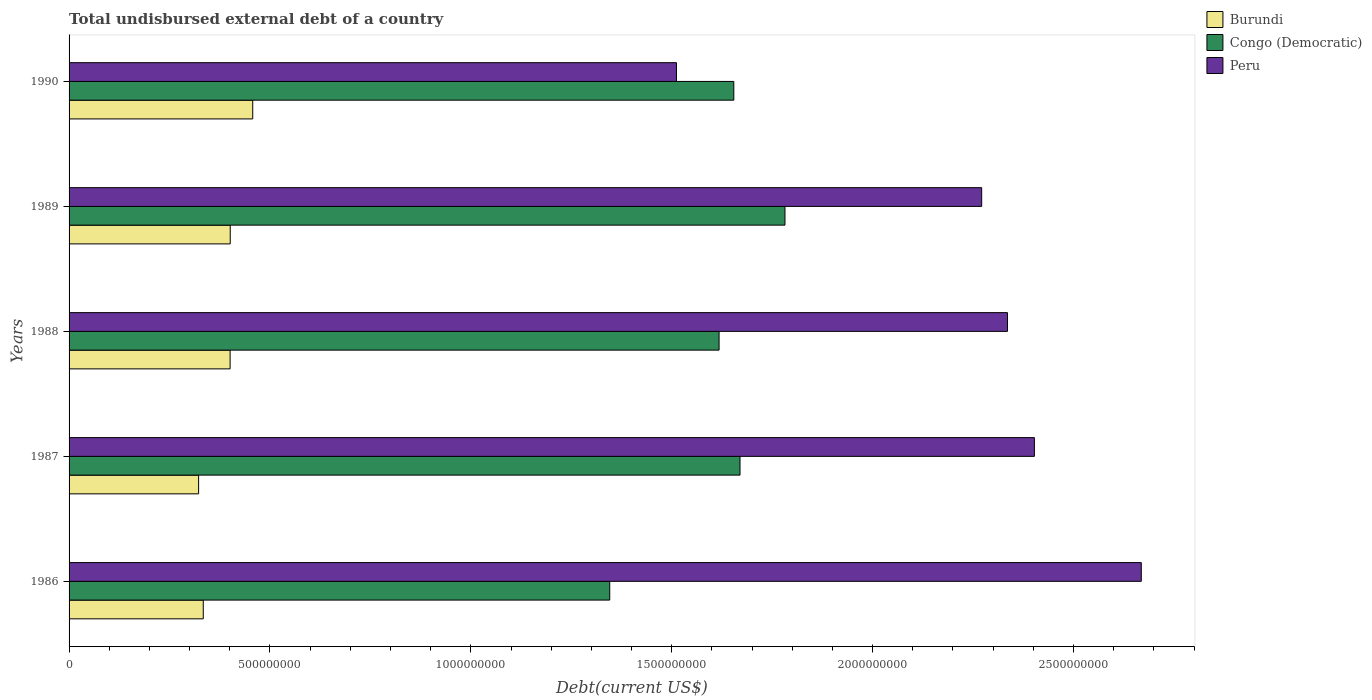What is the label of the 3rd group of bars from the top?
Give a very brief answer. 1988. In how many cases, is the number of bars for a given year not equal to the number of legend labels?
Your response must be concise. 0. What is the total undisbursed external debt in Congo (Democratic) in 1986?
Give a very brief answer. 1.35e+09. Across all years, what is the maximum total undisbursed external debt in Burundi?
Make the answer very short. 4.57e+08. Across all years, what is the minimum total undisbursed external debt in Burundi?
Offer a terse response. 3.22e+08. In which year was the total undisbursed external debt in Congo (Democratic) maximum?
Your answer should be very brief. 1989. What is the total total undisbursed external debt in Peru in the graph?
Give a very brief answer. 1.12e+1. What is the difference between the total undisbursed external debt in Congo (Democratic) in 1986 and that in 1989?
Your answer should be compact. -4.36e+08. What is the difference between the total undisbursed external debt in Congo (Democratic) in 1987 and the total undisbursed external debt in Peru in 1988?
Provide a short and direct response. -6.66e+08. What is the average total undisbursed external debt in Burundi per year?
Offer a very short reply. 3.83e+08. In the year 1987, what is the difference between the total undisbursed external debt in Peru and total undisbursed external debt in Burundi?
Your answer should be compact. 2.08e+09. In how many years, is the total undisbursed external debt in Burundi greater than 2500000000 US$?
Offer a very short reply. 0. What is the ratio of the total undisbursed external debt in Peru in 1988 to that in 1989?
Offer a very short reply. 1.03. Is the difference between the total undisbursed external debt in Peru in 1989 and 1990 greater than the difference between the total undisbursed external debt in Burundi in 1989 and 1990?
Give a very brief answer. Yes. What is the difference between the highest and the second highest total undisbursed external debt in Peru?
Offer a very short reply. 2.66e+08. What is the difference between the highest and the lowest total undisbursed external debt in Peru?
Your response must be concise. 1.16e+09. In how many years, is the total undisbursed external debt in Burundi greater than the average total undisbursed external debt in Burundi taken over all years?
Give a very brief answer. 3. Is the sum of the total undisbursed external debt in Burundi in 1986 and 1989 greater than the maximum total undisbursed external debt in Congo (Democratic) across all years?
Offer a terse response. No. What does the 2nd bar from the top in 1987 represents?
Your answer should be compact. Congo (Democratic). Is it the case that in every year, the sum of the total undisbursed external debt in Burundi and total undisbursed external debt in Congo (Democratic) is greater than the total undisbursed external debt in Peru?
Make the answer very short. No. How many years are there in the graph?
Give a very brief answer. 5. What is the difference between two consecutive major ticks on the X-axis?
Your answer should be very brief. 5.00e+08. Are the values on the major ticks of X-axis written in scientific E-notation?
Your answer should be compact. No. How are the legend labels stacked?
Make the answer very short. Vertical. What is the title of the graph?
Offer a very short reply. Total undisbursed external debt of a country. What is the label or title of the X-axis?
Your response must be concise. Debt(current US$). What is the label or title of the Y-axis?
Offer a very short reply. Years. What is the Debt(current US$) of Burundi in 1986?
Your answer should be compact. 3.34e+08. What is the Debt(current US$) of Congo (Democratic) in 1986?
Give a very brief answer. 1.35e+09. What is the Debt(current US$) in Peru in 1986?
Your answer should be very brief. 2.67e+09. What is the Debt(current US$) of Burundi in 1987?
Your response must be concise. 3.22e+08. What is the Debt(current US$) in Congo (Democratic) in 1987?
Give a very brief answer. 1.67e+09. What is the Debt(current US$) in Peru in 1987?
Your answer should be compact. 2.40e+09. What is the Debt(current US$) of Burundi in 1988?
Ensure brevity in your answer.  4.01e+08. What is the Debt(current US$) of Congo (Democratic) in 1988?
Your answer should be compact. 1.62e+09. What is the Debt(current US$) in Peru in 1988?
Your answer should be very brief. 2.34e+09. What is the Debt(current US$) in Burundi in 1989?
Provide a succinct answer. 4.01e+08. What is the Debt(current US$) of Congo (Democratic) in 1989?
Your response must be concise. 1.78e+09. What is the Debt(current US$) in Peru in 1989?
Make the answer very short. 2.27e+09. What is the Debt(current US$) in Burundi in 1990?
Provide a succinct answer. 4.57e+08. What is the Debt(current US$) of Congo (Democratic) in 1990?
Give a very brief answer. 1.65e+09. What is the Debt(current US$) of Peru in 1990?
Your answer should be compact. 1.51e+09. Across all years, what is the maximum Debt(current US$) in Burundi?
Your response must be concise. 4.57e+08. Across all years, what is the maximum Debt(current US$) of Congo (Democratic)?
Give a very brief answer. 1.78e+09. Across all years, what is the maximum Debt(current US$) of Peru?
Make the answer very short. 2.67e+09. Across all years, what is the minimum Debt(current US$) in Burundi?
Make the answer very short. 3.22e+08. Across all years, what is the minimum Debt(current US$) in Congo (Democratic)?
Your answer should be very brief. 1.35e+09. Across all years, what is the minimum Debt(current US$) in Peru?
Ensure brevity in your answer.  1.51e+09. What is the total Debt(current US$) of Burundi in the graph?
Make the answer very short. 1.92e+09. What is the total Debt(current US$) of Congo (Democratic) in the graph?
Offer a terse response. 8.07e+09. What is the total Debt(current US$) of Peru in the graph?
Offer a terse response. 1.12e+1. What is the difference between the Debt(current US$) in Burundi in 1986 and that in 1987?
Give a very brief answer. 1.16e+07. What is the difference between the Debt(current US$) of Congo (Democratic) in 1986 and that in 1987?
Provide a short and direct response. -3.24e+08. What is the difference between the Debt(current US$) of Peru in 1986 and that in 1987?
Offer a terse response. 2.66e+08. What is the difference between the Debt(current US$) in Burundi in 1986 and that in 1988?
Provide a succinct answer. -6.68e+07. What is the difference between the Debt(current US$) in Congo (Democratic) in 1986 and that in 1988?
Your response must be concise. -2.72e+08. What is the difference between the Debt(current US$) in Peru in 1986 and that in 1988?
Offer a terse response. 3.33e+08. What is the difference between the Debt(current US$) of Burundi in 1986 and that in 1989?
Offer a terse response. -6.71e+07. What is the difference between the Debt(current US$) in Congo (Democratic) in 1986 and that in 1989?
Your answer should be compact. -4.36e+08. What is the difference between the Debt(current US$) of Peru in 1986 and that in 1989?
Make the answer very short. 3.97e+08. What is the difference between the Debt(current US$) of Burundi in 1986 and that in 1990?
Provide a short and direct response. -1.23e+08. What is the difference between the Debt(current US$) in Congo (Democratic) in 1986 and that in 1990?
Your response must be concise. -3.09e+08. What is the difference between the Debt(current US$) of Peru in 1986 and that in 1990?
Your answer should be compact. 1.16e+09. What is the difference between the Debt(current US$) in Burundi in 1987 and that in 1988?
Make the answer very short. -7.84e+07. What is the difference between the Debt(current US$) of Congo (Democratic) in 1987 and that in 1988?
Your answer should be compact. 5.21e+07. What is the difference between the Debt(current US$) in Peru in 1987 and that in 1988?
Your answer should be very brief. 6.70e+07. What is the difference between the Debt(current US$) in Burundi in 1987 and that in 1989?
Your answer should be compact. -7.87e+07. What is the difference between the Debt(current US$) of Congo (Democratic) in 1987 and that in 1989?
Give a very brief answer. -1.12e+08. What is the difference between the Debt(current US$) in Peru in 1987 and that in 1989?
Make the answer very short. 1.31e+08. What is the difference between the Debt(current US$) of Burundi in 1987 and that in 1990?
Make the answer very short. -1.35e+08. What is the difference between the Debt(current US$) of Congo (Democratic) in 1987 and that in 1990?
Ensure brevity in your answer.  1.54e+07. What is the difference between the Debt(current US$) of Peru in 1987 and that in 1990?
Make the answer very short. 8.91e+08. What is the difference between the Debt(current US$) of Burundi in 1988 and that in 1989?
Your answer should be very brief. -3.04e+05. What is the difference between the Debt(current US$) of Congo (Democratic) in 1988 and that in 1989?
Make the answer very short. -1.64e+08. What is the difference between the Debt(current US$) of Peru in 1988 and that in 1989?
Offer a terse response. 6.43e+07. What is the difference between the Debt(current US$) of Burundi in 1988 and that in 1990?
Keep it short and to the point. -5.63e+07. What is the difference between the Debt(current US$) of Congo (Democratic) in 1988 and that in 1990?
Provide a short and direct response. -3.67e+07. What is the difference between the Debt(current US$) of Peru in 1988 and that in 1990?
Your answer should be compact. 8.24e+08. What is the difference between the Debt(current US$) of Burundi in 1989 and that in 1990?
Keep it short and to the point. -5.60e+07. What is the difference between the Debt(current US$) in Congo (Democratic) in 1989 and that in 1990?
Your answer should be very brief. 1.27e+08. What is the difference between the Debt(current US$) of Peru in 1989 and that in 1990?
Ensure brevity in your answer.  7.60e+08. What is the difference between the Debt(current US$) of Burundi in 1986 and the Debt(current US$) of Congo (Democratic) in 1987?
Offer a very short reply. -1.34e+09. What is the difference between the Debt(current US$) in Burundi in 1986 and the Debt(current US$) in Peru in 1987?
Offer a terse response. -2.07e+09. What is the difference between the Debt(current US$) of Congo (Democratic) in 1986 and the Debt(current US$) of Peru in 1987?
Provide a short and direct response. -1.06e+09. What is the difference between the Debt(current US$) of Burundi in 1986 and the Debt(current US$) of Congo (Democratic) in 1988?
Provide a succinct answer. -1.28e+09. What is the difference between the Debt(current US$) of Burundi in 1986 and the Debt(current US$) of Peru in 1988?
Ensure brevity in your answer.  -2.00e+09. What is the difference between the Debt(current US$) of Congo (Democratic) in 1986 and the Debt(current US$) of Peru in 1988?
Provide a short and direct response. -9.90e+08. What is the difference between the Debt(current US$) of Burundi in 1986 and the Debt(current US$) of Congo (Democratic) in 1989?
Keep it short and to the point. -1.45e+09. What is the difference between the Debt(current US$) of Burundi in 1986 and the Debt(current US$) of Peru in 1989?
Your answer should be compact. -1.94e+09. What is the difference between the Debt(current US$) of Congo (Democratic) in 1986 and the Debt(current US$) of Peru in 1989?
Keep it short and to the point. -9.26e+08. What is the difference between the Debt(current US$) of Burundi in 1986 and the Debt(current US$) of Congo (Democratic) in 1990?
Offer a terse response. -1.32e+09. What is the difference between the Debt(current US$) of Burundi in 1986 and the Debt(current US$) of Peru in 1990?
Offer a very short reply. -1.18e+09. What is the difference between the Debt(current US$) in Congo (Democratic) in 1986 and the Debt(current US$) in Peru in 1990?
Offer a very short reply. -1.66e+08. What is the difference between the Debt(current US$) in Burundi in 1987 and the Debt(current US$) in Congo (Democratic) in 1988?
Keep it short and to the point. -1.30e+09. What is the difference between the Debt(current US$) in Burundi in 1987 and the Debt(current US$) in Peru in 1988?
Your answer should be very brief. -2.01e+09. What is the difference between the Debt(current US$) in Congo (Democratic) in 1987 and the Debt(current US$) in Peru in 1988?
Keep it short and to the point. -6.66e+08. What is the difference between the Debt(current US$) of Burundi in 1987 and the Debt(current US$) of Congo (Democratic) in 1989?
Offer a very short reply. -1.46e+09. What is the difference between the Debt(current US$) of Burundi in 1987 and the Debt(current US$) of Peru in 1989?
Your answer should be very brief. -1.95e+09. What is the difference between the Debt(current US$) in Congo (Democratic) in 1987 and the Debt(current US$) in Peru in 1989?
Offer a terse response. -6.01e+08. What is the difference between the Debt(current US$) of Burundi in 1987 and the Debt(current US$) of Congo (Democratic) in 1990?
Make the answer very short. -1.33e+09. What is the difference between the Debt(current US$) in Burundi in 1987 and the Debt(current US$) in Peru in 1990?
Give a very brief answer. -1.19e+09. What is the difference between the Debt(current US$) in Congo (Democratic) in 1987 and the Debt(current US$) in Peru in 1990?
Provide a succinct answer. 1.58e+08. What is the difference between the Debt(current US$) of Burundi in 1988 and the Debt(current US$) of Congo (Democratic) in 1989?
Provide a short and direct response. -1.38e+09. What is the difference between the Debt(current US$) in Burundi in 1988 and the Debt(current US$) in Peru in 1989?
Your response must be concise. -1.87e+09. What is the difference between the Debt(current US$) of Congo (Democratic) in 1988 and the Debt(current US$) of Peru in 1989?
Make the answer very short. -6.54e+08. What is the difference between the Debt(current US$) in Burundi in 1988 and the Debt(current US$) in Congo (Democratic) in 1990?
Your answer should be very brief. -1.25e+09. What is the difference between the Debt(current US$) of Burundi in 1988 and the Debt(current US$) of Peru in 1990?
Offer a terse response. -1.11e+09. What is the difference between the Debt(current US$) of Congo (Democratic) in 1988 and the Debt(current US$) of Peru in 1990?
Ensure brevity in your answer.  1.06e+08. What is the difference between the Debt(current US$) of Burundi in 1989 and the Debt(current US$) of Congo (Democratic) in 1990?
Ensure brevity in your answer.  -1.25e+09. What is the difference between the Debt(current US$) in Burundi in 1989 and the Debt(current US$) in Peru in 1990?
Provide a short and direct response. -1.11e+09. What is the difference between the Debt(current US$) of Congo (Democratic) in 1989 and the Debt(current US$) of Peru in 1990?
Ensure brevity in your answer.  2.70e+08. What is the average Debt(current US$) in Burundi per year?
Your answer should be compact. 3.83e+08. What is the average Debt(current US$) in Congo (Democratic) per year?
Make the answer very short. 1.61e+09. What is the average Debt(current US$) of Peru per year?
Keep it short and to the point. 2.24e+09. In the year 1986, what is the difference between the Debt(current US$) in Burundi and Debt(current US$) in Congo (Democratic)?
Your response must be concise. -1.01e+09. In the year 1986, what is the difference between the Debt(current US$) in Burundi and Debt(current US$) in Peru?
Provide a succinct answer. -2.33e+09. In the year 1986, what is the difference between the Debt(current US$) in Congo (Democratic) and Debt(current US$) in Peru?
Your answer should be very brief. -1.32e+09. In the year 1987, what is the difference between the Debt(current US$) in Burundi and Debt(current US$) in Congo (Democratic)?
Make the answer very short. -1.35e+09. In the year 1987, what is the difference between the Debt(current US$) in Burundi and Debt(current US$) in Peru?
Keep it short and to the point. -2.08e+09. In the year 1987, what is the difference between the Debt(current US$) in Congo (Democratic) and Debt(current US$) in Peru?
Offer a very short reply. -7.33e+08. In the year 1988, what is the difference between the Debt(current US$) of Burundi and Debt(current US$) of Congo (Democratic)?
Make the answer very short. -1.22e+09. In the year 1988, what is the difference between the Debt(current US$) in Burundi and Debt(current US$) in Peru?
Provide a short and direct response. -1.93e+09. In the year 1988, what is the difference between the Debt(current US$) of Congo (Democratic) and Debt(current US$) of Peru?
Provide a succinct answer. -7.18e+08. In the year 1989, what is the difference between the Debt(current US$) of Burundi and Debt(current US$) of Congo (Democratic)?
Keep it short and to the point. -1.38e+09. In the year 1989, what is the difference between the Debt(current US$) in Burundi and Debt(current US$) in Peru?
Give a very brief answer. -1.87e+09. In the year 1989, what is the difference between the Debt(current US$) in Congo (Democratic) and Debt(current US$) in Peru?
Ensure brevity in your answer.  -4.90e+08. In the year 1990, what is the difference between the Debt(current US$) of Burundi and Debt(current US$) of Congo (Democratic)?
Provide a succinct answer. -1.20e+09. In the year 1990, what is the difference between the Debt(current US$) of Burundi and Debt(current US$) of Peru?
Keep it short and to the point. -1.05e+09. In the year 1990, what is the difference between the Debt(current US$) in Congo (Democratic) and Debt(current US$) in Peru?
Offer a very short reply. 1.43e+08. What is the ratio of the Debt(current US$) of Burundi in 1986 to that in 1987?
Keep it short and to the point. 1.04. What is the ratio of the Debt(current US$) in Congo (Democratic) in 1986 to that in 1987?
Your answer should be compact. 0.81. What is the ratio of the Debt(current US$) of Peru in 1986 to that in 1987?
Your answer should be very brief. 1.11. What is the ratio of the Debt(current US$) of Congo (Democratic) in 1986 to that in 1988?
Provide a short and direct response. 0.83. What is the ratio of the Debt(current US$) of Peru in 1986 to that in 1988?
Your answer should be very brief. 1.14. What is the ratio of the Debt(current US$) in Burundi in 1986 to that in 1989?
Your response must be concise. 0.83. What is the ratio of the Debt(current US$) in Congo (Democratic) in 1986 to that in 1989?
Ensure brevity in your answer.  0.76. What is the ratio of the Debt(current US$) of Peru in 1986 to that in 1989?
Your response must be concise. 1.17. What is the ratio of the Debt(current US$) in Burundi in 1986 to that in 1990?
Provide a succinct answer. 0.73. What is the ratio of the Debt(current US$) in Congo (Democratic) in 1986 to that in 1990?
Offer a terse response. 0.81. What is the ratio of the Debt(current US$) in Peru in 1986 to that in 1990?
Your answer should be very brief. 1.77. What is the ratio of the Debt(current US$) in Burundi in 1987 to that in 1988?
Offer a very short reply. 0.8. What is the ratio of the Debt(current US$) of Congo (Democratic) in 1987 to that in 1988?
Offer a terse response. 1.03. What is the ratio of the Debt(current US$) of Peru in 1987 to that in 1988?
Give a very brief answer. 1.03. What is the ratio of the Debt(current US$) in Burundi in 1987 to that in 1989?
Ensure brevity in your answer.  0.8. What is the ratio of the Debt(current US$) in Congo (Democratic) in 1987 to that in 1989?
Offer a terse response. 0.94. What is the ratio of the Debt(current US$) in Peru in 1987 to that in 1989?
Give a very brief answer. 1.06. What is the ratio of the Debt(current US$) of Burundi in 1987 to that in 1990?
Give a very brief answer. 0.71. What is the ratio of the Debt(current US$) of Congo (Democratic) in 1987 to that in 1990?
Your answer should be very brief. 1.01. What is the ratio of the Debt(current US$) of Peru in 1987 to that in 1990?
Your response must be concise. 1.59. What is the ratio of the Debt(current US$) in Burundi in 1988 to that in 1989?
Offer a very short reply. 1. What is the ratio of the Debt(current US$) in Congo (Democratic) in 1988 to that in 1989?
Provide a short and direct response. 0.91. What is the ratio of the Debt(current US$) in Peru in 1988 to that in 1989?
Offer a terse response. 1.03. What is the ratio of the Debt(current US$) of Burundi in 1988 to that in 1990?
Your answer should be compact. 0.88. What is the ratio of the Debt(current US$) of Congo (Democratic) in 1988 to that in 1990?
Offer a very short reply. 0.98. What is the ratio of the Debt(current US$) in Peru in 1988 to that in 1990?
Give a very brief answer. 1.54. What is the ratio of the Debt(current US$) of Burundi in 1989 to that in 1990?
Provide a succinct answer. 0.88. What is the ratio of the Debt(current US$) in Congo (Democratic) in 1989 to that in 1990?
Offer a terse response. 1.08. What is the ratio of the Debt(current US$) of Peru in 1989 to that in 1990?
Offer a very short reply. 1.5. What is the difference between the highest and the second highest Debt(current US$) in Burundi?
Your answer should be very brief. 5.60e+07. What is the difference between the highest and the second highest Debt(current US$) in Congo (Democratic)?
Provide a short and direct response. 1.12e+08. What is the difference between the highest and the second highest Debt(current US$) in Peru?
Offer a very short reply. 2.66e+08. What is the difference between the highest and the lowest Debt(current US$) of Burundi?
Make the answer very short. 1.35e+08. What is the difference between the highest and the lowest Debt(current US$) in Congo (Democratic)?
Offer a very short reply. 4.36e+08. What is the difference between the highest and the lowest Debt(current US$) in Peru?
Ensure brevity in your answer.  1.16e+09. 